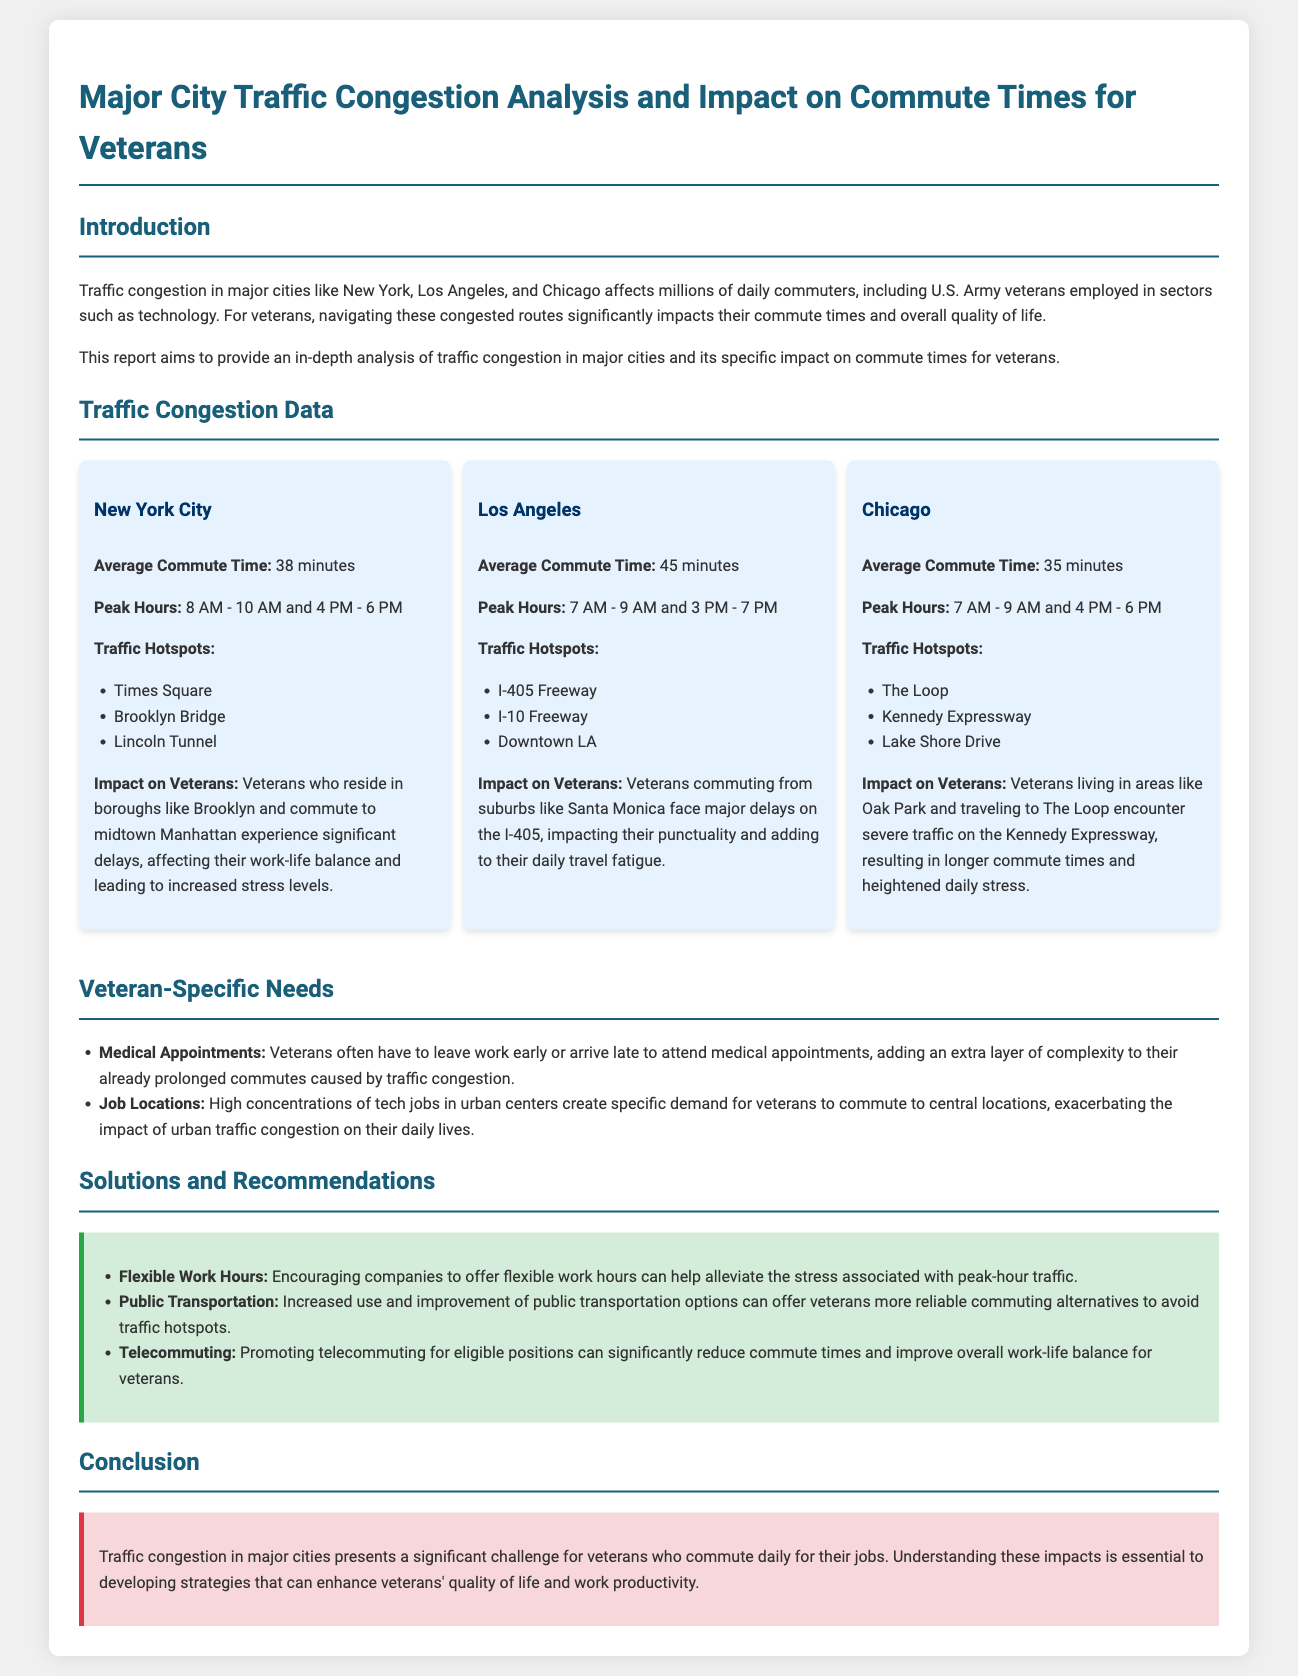What is the average commute time in New York City? The average commute time in New York City is specified in the section "Traffic Congestion Data" under New York City.
Answer: 38 minutes What are the peak hours for Los Angeles traffic? The peak hours for Los Angeles traffic are listed in the "Traffic Congestion Data" section under Los Angeles.
Answer: 7 AM - 9 AM and 3 PM - 7 PM Which city has the highest average commute time? The average commute times for each city are summarized in the "Traffic Congestion Data" section, allowing for comparison.
Answer: Los Angeles What are the traffic hotspots in Chicago? The traffic hotspots in Chicago are mentioned in the "Traffic Congestion Data" section under Chicago.
Answer: The Loop, Kennedy Expressway, Lake Shore Drive How do flexible work hours help veterans? The document suggests solutions to alleviate traffic congestion, where flexible work hours are proposed as a potential benefit for veterans.
Answer: Alleviate stress What type of commuting option is recommended for veterans to improve reliability? The "Solutions and Recommendations" section suggests options for veterans to better manage their commutes.
Answer: Public Transportation What is the main focus of the report? The introduction outlines the report's central theme concerning traffic congestion and veterans' commute times.
Answer: Traffic congestion and veterans What are veterans often required to attend that complicates their commute? The "Veteran-Specific Needs" section describes additional responsibilities for veterans that may affect commuting.
Answer: Medical appointments How does traffic congestion affect veterans' work-life balance? The document discusses the specific impact of traffic congestion on veterans and how it intertwines with their daily lives.
Answer: Increases stress levels 